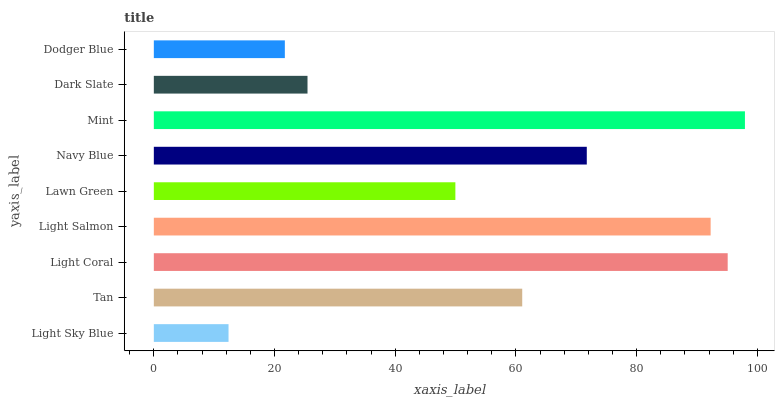Is Light Sky Blue the minimum?
Answer yes or no. Yes. Is Mint the maximum?
Answer yes or no. Yes. Is Tan the minimum?
Answer yes or no. No. Is Tan the maximum?
Answer yes or no. No. Is Tan greater than Light Sky Blue?
Answer yes or no. Yes. Is Light Sky Blue less than Tan?
Answer yes or no. Yes. Is Light Sky Blue greater than Tan?
Answer yes or no. No. Is Tan less than Light Sky Blue?
Answer yes or no. No. Is Tan the high median?
Answer yes or no. Yes. Is Tan the low median?
Answer yes or no. Yes. Is Light Sky Blue the high median?
Answer yes or no. No. Is Navy Blue the low median?
Answer yes or no. No. 